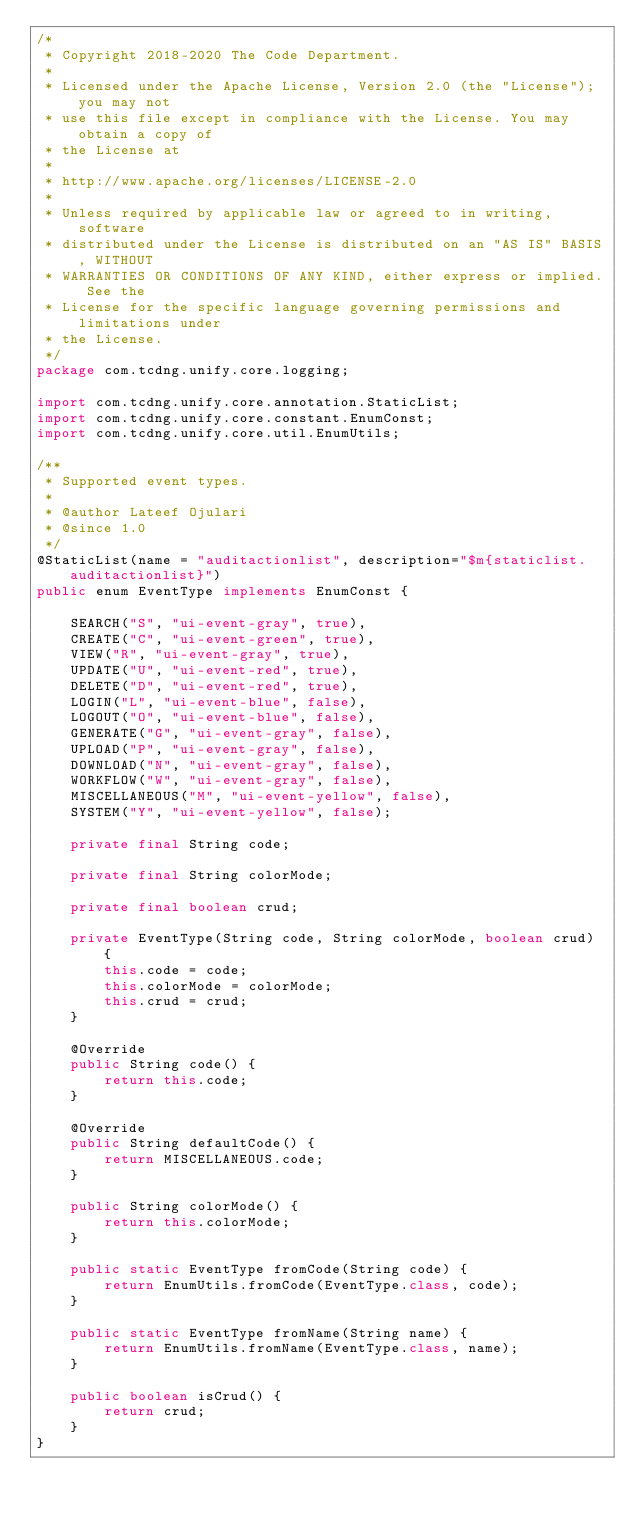<code> <loc_0><loc_0><loc_500><loc_500><_Java_>/*
 * Copyright 2018-2020 The Code Department.
 * 
 * Licensed under the Apache License, Version 2.0 (the "License"); you may not
 * use this file except in compliance with the License. You may obtain a copy of
 * the License at
 * 
 * http://www.apache.org/licenses/LICENSE-2.0
 * 
 * Unless required by applicable law or agreed to in writing, software
 * distributed under the License is distributed on an "AS IS" BASIS, WITHOUT
 * WARRANTIES OR CONDITIONS OF ANY KIND, either express or implied. See the
 * License for the specific language governing permissions and limitations under
 * the License.
 */
package com.tcdng.unify.core.logging;

import com.tcdng.unify.core.annotation.StaticList;
import com.tcdng.unify.core.constant.EnumConst;
import com.tcdng.unify.core.util.EnumUtils;

/**
 * Supported event types.
 * 
 * @author Lateef Ojulari
 * @since 1.0
 */
@StaticList(name = "auditactionlist", description="$m{staticlist.auditactionlist}")
public enum EventType implements EnumConst {

    SEARCH("S", "ui-event-gray", true),
    CREATE("C", "ui-event-green", true),
    VIEW("R", "ui-event-gray", true),
    UPDATE("U", "ui-event-red", true),
    DELETE("D", "ui-event-red", true),
    LOGIN("L", "ui-event-blue", false),
    LOGOUT("O", "ui-event-blue", false),
    GENERATE("G", "ui-event-gray", false),
    UPLOAD("P", "ui-event-gray", false),
    DOWNLOAD("N", "ui-event-gray", false),
    WORKFLOW("W", "ui-event-gray", false),
    MISCELLANEOUS("M", "ui-event-yellow", false),
    SYSTEM("Y", "ui-event-yellow", false);

    private final String code;

    private final String colorMode;

    private final boolean crud;

    private EventType(String code, String colorMode, boolean crud) {
        this.code = code;
        this.colorMode = colorMode;
        this.crud = crud;
    }

    @Override
    public String code() {
        return this.code;
    }

    @Override
    public String defaultCode() {
        return MISCELLANEOUS.code;
    }

    public String colorMode() {
        return this.colorMode;
    }

    public static EventType fromCode(String code) {
        return EnumUtils.fromCode(EventType.class, code);
    }

    public static EventType fromName(String name) {
        return EnumUtils.fromName(EventType.class, name);
    }

    public boolean isCrud() {
        return crud;
    }
}
</code> 